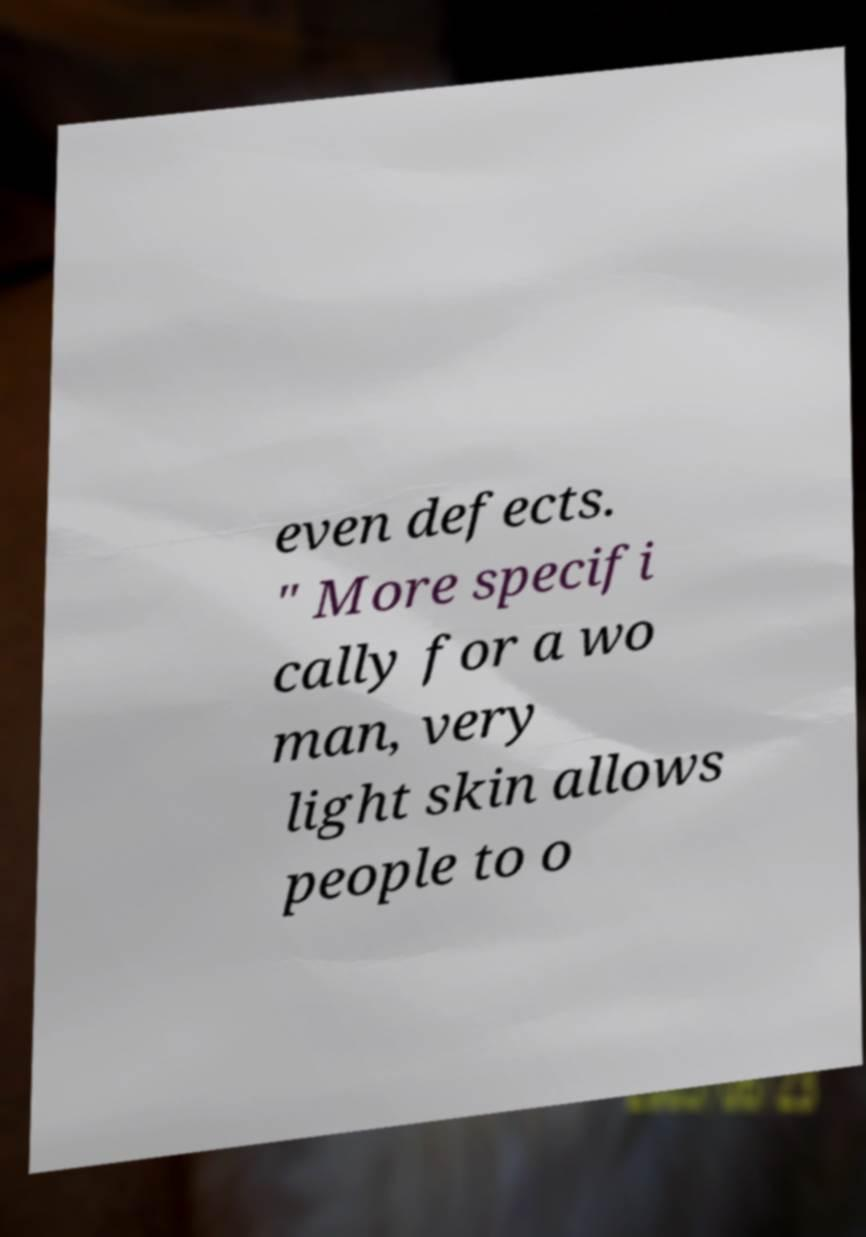There's text embedded in this image that I need extracted. Can you transcribe it verbatim? even defects. " More specifi cally for a wo man, very light skin allows people to o 